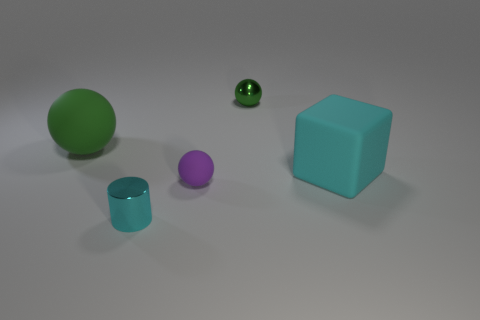Is the size of the cyan object behind the cyan metal thing the same as the green rubber sphere?
Give a very brief answer. Yes. What is the size of the rubber object that is right of the shiny sphere?
Your answer should be very brief. Large. Are there any other things that have the same material as the cylinder?
Provide a succinct answer. Yes. What number of metal spheres are there?
Give a very brief answer. 1. Is the metal ball the same color as the small metal cylinder?
Offer a very short reply. No. There is a rubber object that is left of the big cyan object and in front of the green matte object; what is its color?
Your answer should be very brief. Purple. Are there any purple things in front of the tiny cyan shiny thing?
Offer a terse response. No. What number of cyan shiny cylinders are on the right side of the tiny purple ball in front of the cyan block?
Keep it short and to the point. 0. What size is the cyan thing that is the same material as the purple thing?
Provide a short and direct response. Large. What size is the green matte object?
Offer a terse response. Large. 